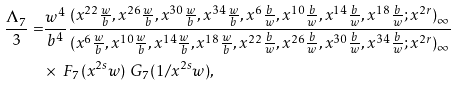Convert formula to latex. <formula><loc_0><loc_0><loc_500><loc_500>\frac { \Lambda _ { 7 } } { 3 } = & \frac { w ^ { 4 } } { b ^ { 4 } } \frac { ( x ^ { 2 2 } \frac { w } { b } , x ^ { 2 6 } \frac { w } { b } , x ^ { 3 0 } \frac { w } { b } , x ^ { 3 4 } \frac { w } { b } , x ^ { 6 } \frac { b } { w } , x ^ { 1 0 } \frac { b } { w } , x ^ { 1 4 } \frac { b } { w } , x ^ { 1 8 } \frac { b } { w } ; x ^ { 2 r } ) _ { \infty } } { ( x ^ { 6 } \frac { w } { b } , x ^ { 1 0 } \frac { w } { b } , x ^ { 1 4 } \frac { w } { b } , x ^ { 1 8 } \frac { w } { b } , x ^ { 2 2 } \frac { b } { w } , x ^ { 2 6 } \frac { b } { w } , x ^ { 3 0 } \frac { b } { w } , x ^ { 3 4 } \frac { b } { w } ; x ^ { 2 r } ) _ { \infty } } \\ & \times \ F _ { 7 } ( x ^ { 2 s } w ) \ G _ { 7 } ( 1 / x ^ { 2 s } w ) ,</formula> 